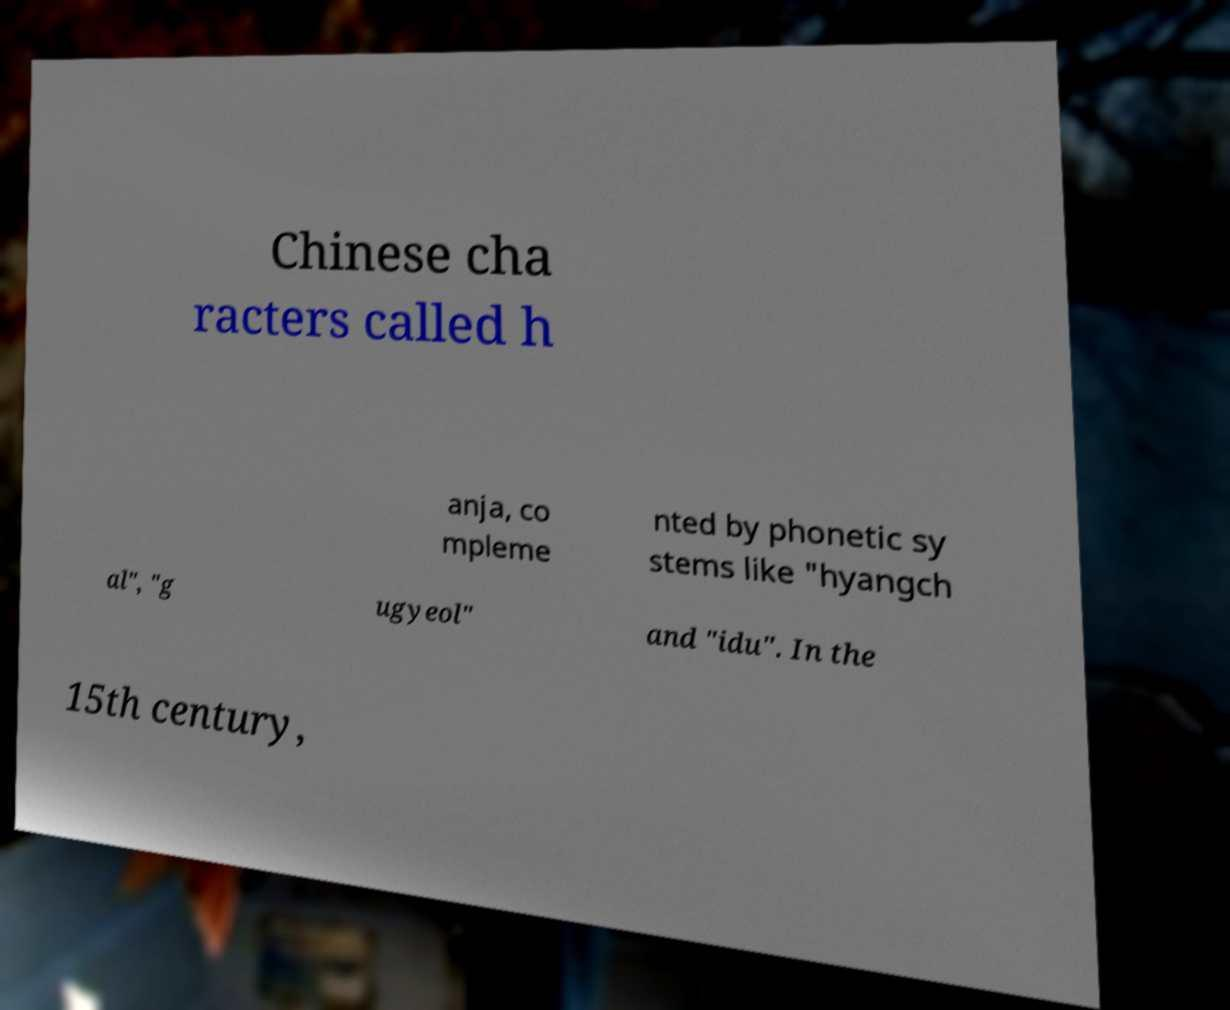For documentation purposes, I need the text within this image transcribed. Could you provide that? Chinese cha racters called h anja, co mpleme nted by phonetic sy stems like "hyangch al", "g ugyeol" and "idu". In the 15th century, 